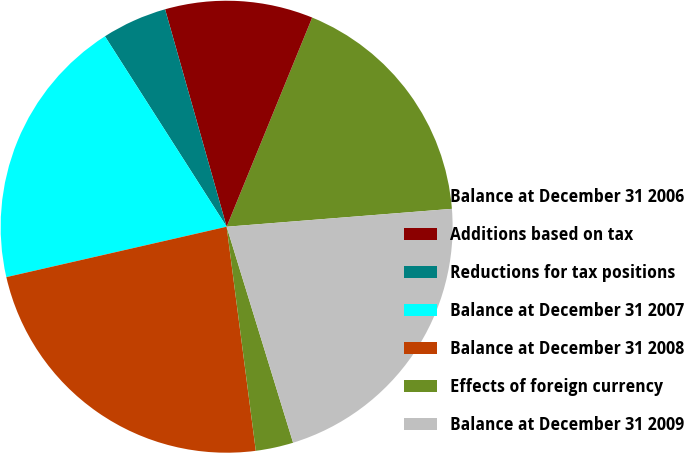Convert chart. <chart><loc_0><loc_0><loc_500><loc_500><pie_chart><fcel>Balance at December 31 2006<fcel>Additions based on tax<fcel>Reductions for tax positions<fcel>Balance at December 31 2007<fcel>Balance at December 31 2008<fcel>Effects of foreign currency<fcel>Balance at December 31 2009<nl><fcel>17.56%<fcel>10.57%<fcel>4.66%<fcel>19.53%<fcel>23.48%<fcel>2.69%<fcel>21.51%<nl></chart> 